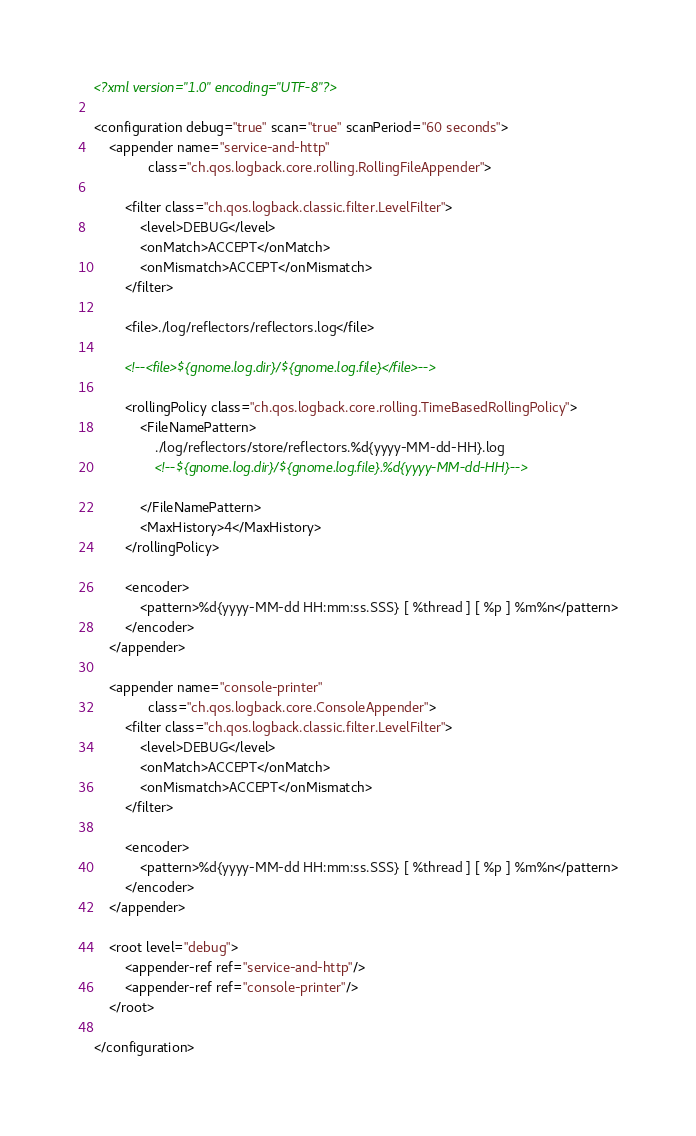Convert code to text. <code><loc_0><loc_0><loc_500><loc_500><_XML_><?xml version="1.0" encoding="UTF-8"?>

<configuration debug="true" scan="true" scanPeriod="60 seconds">
    <appender name="service-and-http"
              class="ch.qos.logback.core.rolling.RollingFileAppender">

        <filter class="ch.qos.logback.classic.filter.LevelFilter">
            <level>DEBUG</level>
            <onMatch>ACCEPT</onMatch>
            <onMismatch>ACCEPT</onMismatch>
        </filter>

        <file>./log/reflectors/reflectors.log</file>

        <!--<file>${gnome.log.dir}/${gnome.log.file}</file>-->

        <rollingPolicy class="ch.qos.logback.core.rolling.TimeBasedRollingPolicy">
            <FileNamePattern>
                ./log/reflectors/store/reflectors.%d{yyyy-MM-dd-HH}.log
                <!--${gnome.log.dir}/${gnome.log.file}.%d{yyyy-MM-dd-HH}-->

            </FileNamePattern>
            <MaxHistory>4</MaxHistory>
        </rollingPolicy>

        <encoder>
            <pattern>%d{yyyy-MM-dd HH:mm:ss.SSS} [ %thread ] [ %p ] %m%n</pattern>
        </encoder>
    </appender>

    <appender name="console-printer"
              class="ch.qos.logback.core.ConsoleAppender">
        <filter class="ch.qos.logback.classic.filter.LevelFilter">
            <level>DEBUG</level>
            <onMatch>ACCEPT</onMatch>
            <onMismatch>ACCEPT</onMismatch>
        </filter>

        <encoder>
            <pattern>%d{yyyy-MM-dd HH:mm:ss.SSS} [ %thread ] [ %p ] %m%n</pattern>
        </encoder>
    </appender>

    <root level="debug">
        <appender-ref ref="service-and-http"/>
        <appender-ref ref="console-printer"/>
    </root>

</configuration>
</code> 